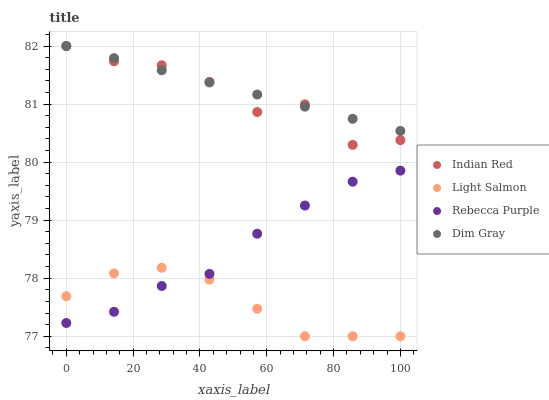Does Light Salmon have the minimum area under the curve?
Answer yes or no. Yes. Does Dim Gray have the maximum area under the curve?
Answer yes or no. Yes. Does Rebecca Purple have the minimum area under the curve?
Answer yes or no. No. Does Rebecca Purple have the maximum area under the curve?
Answer yes or no. No. Is Dim Gray the smoothest?
Answer yes or no. Yes. Is Indian Red the roughest?
Answer yes or no. Yes. Is Rebecca Purple the smoothest?
Answer yes or no. No. Is Rebecca Purple the roughest?
Answer yes or no. No. Does Light Salmon have the lowest value?
Answer yes or no. Yes. Does Rebecca Purple have the lowest value?
Answer yes or no. No. Does Indian Red have the highest value?
Answer yes or no. Yes. Does Rebecca Purple have the highest value?
Answer yes or no. No. Is Rebecca Purple less than Indian Red?
Answer yes or no. Yes. Is Dim Gray greater than Rebecca Purple?
Answer yes or no. Yes. Does Rebecca Purple intersect Light Salmon?
Answer yes or no. Yes. Is Rebecca Purple less than Light Salmon?
Answer yes or no. No. Is Rebecca Purple greater than Light Salmon?
Answer yes or no. No. Does Rebecca Purple intersect Indian Red?
Answer yes or no. No. 